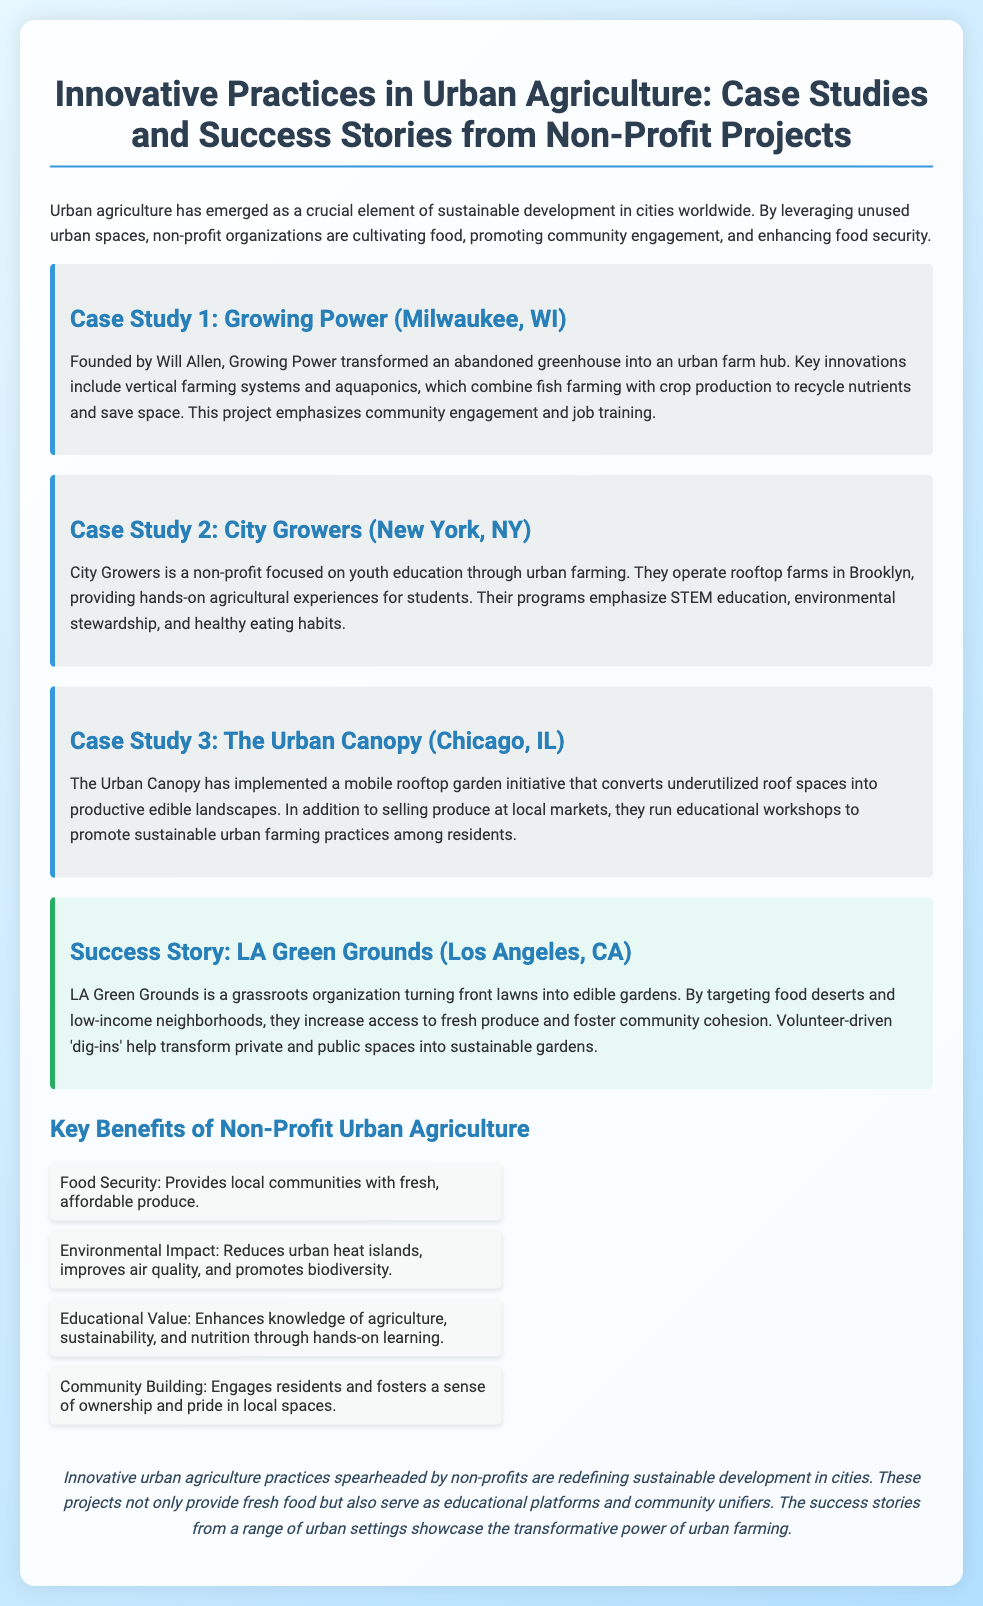What is the title of the presentation? The title of the presentation is the header of the document, which provides the main topic covered.
Answer: Innovative Practices in Urban Agriculture: Case Studies and Success Stories from Non-Profit Projects How many case studies are presented? The number of case studies can be counted from the segments labeled as case studies within the document.
Answer: 3 Which organization transformed an abandoned greenhouse? This can be identified in the section describing the first case study, which focuses on a specific organization and its transformation efforts.
Answer: Growing Power What is the main focus of City Growers? The focus can be determined by the description provided in the second case study, specifically mentioning the target demographic and educational goals.
Answer: Youth education What benefit of urban agriculture is related to environmental impact? This benefit can be referenced in the section discussing key benefits, particularly focusing on the aspects that impact the environment.
Answer: Reduces urban heat islands Which city is associated with the success story of LA Green Grounds? The city linked to this success story is mentioned explicitly in the introduction of the section describing the success story.
Answer: Los Angeles What agricultural technique combines fish farming with crop production? This technique is highlighted in the explanation of the first case study as a key innovation used by the organization.
Answer: Aquaponics What is a key outcome of volunteer-driven 'dig-ins'? The outcome of these activities can be inferred from the description of the success story, outlining what volunteers help achieve.
Answer: Transform gardens What type of impact do urban agriculture practices have on community? The impact is summarized in the section discussing benefits and emphasizes community engagement and ownership.
Answer: Community Building 